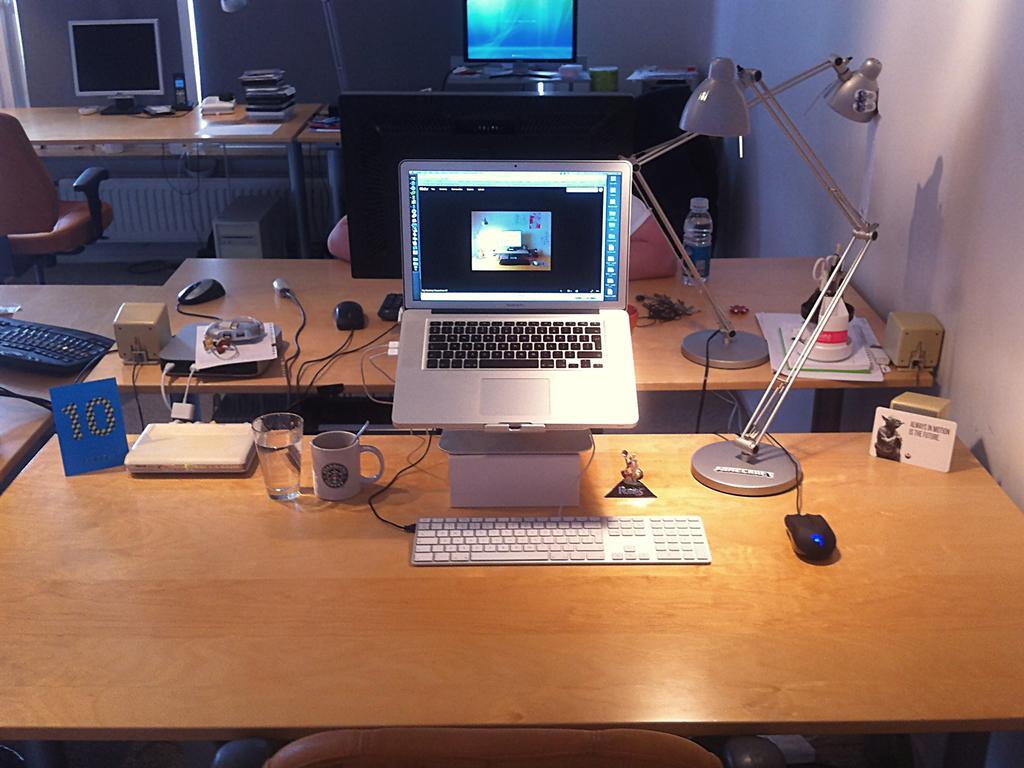Describe this image in one or two sentences. In this picture there is a table on which a laptop keyboard, mouse, some glasses and books were placed. There is lamp placed on the table. In the background there is a chair and some tables here. We can observe a wall in the right side. 